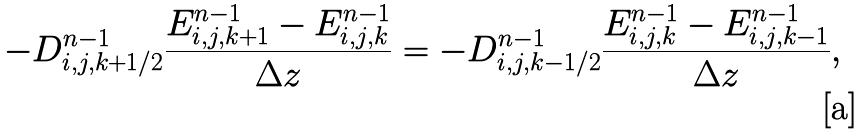<formula> <loc_0><loc_0><loc_500><loc_500>- D _ { i , j , k + 1 / 2 } ^ { n - 1 } \frac { E _ { i , j , k + 1 } ^ { n - 1 } - E _ { i , j , k } ^ { n - 1 } } { \Delta z } = - D _ { i , j , k - 1 / 2 } ^ { n - 1 } \frac { E _ { i , j , k } ^ { n - 1 } - E _ { i , j , k - 1 } ^ { n - 1 } } { \Delta z } ,</formula> 